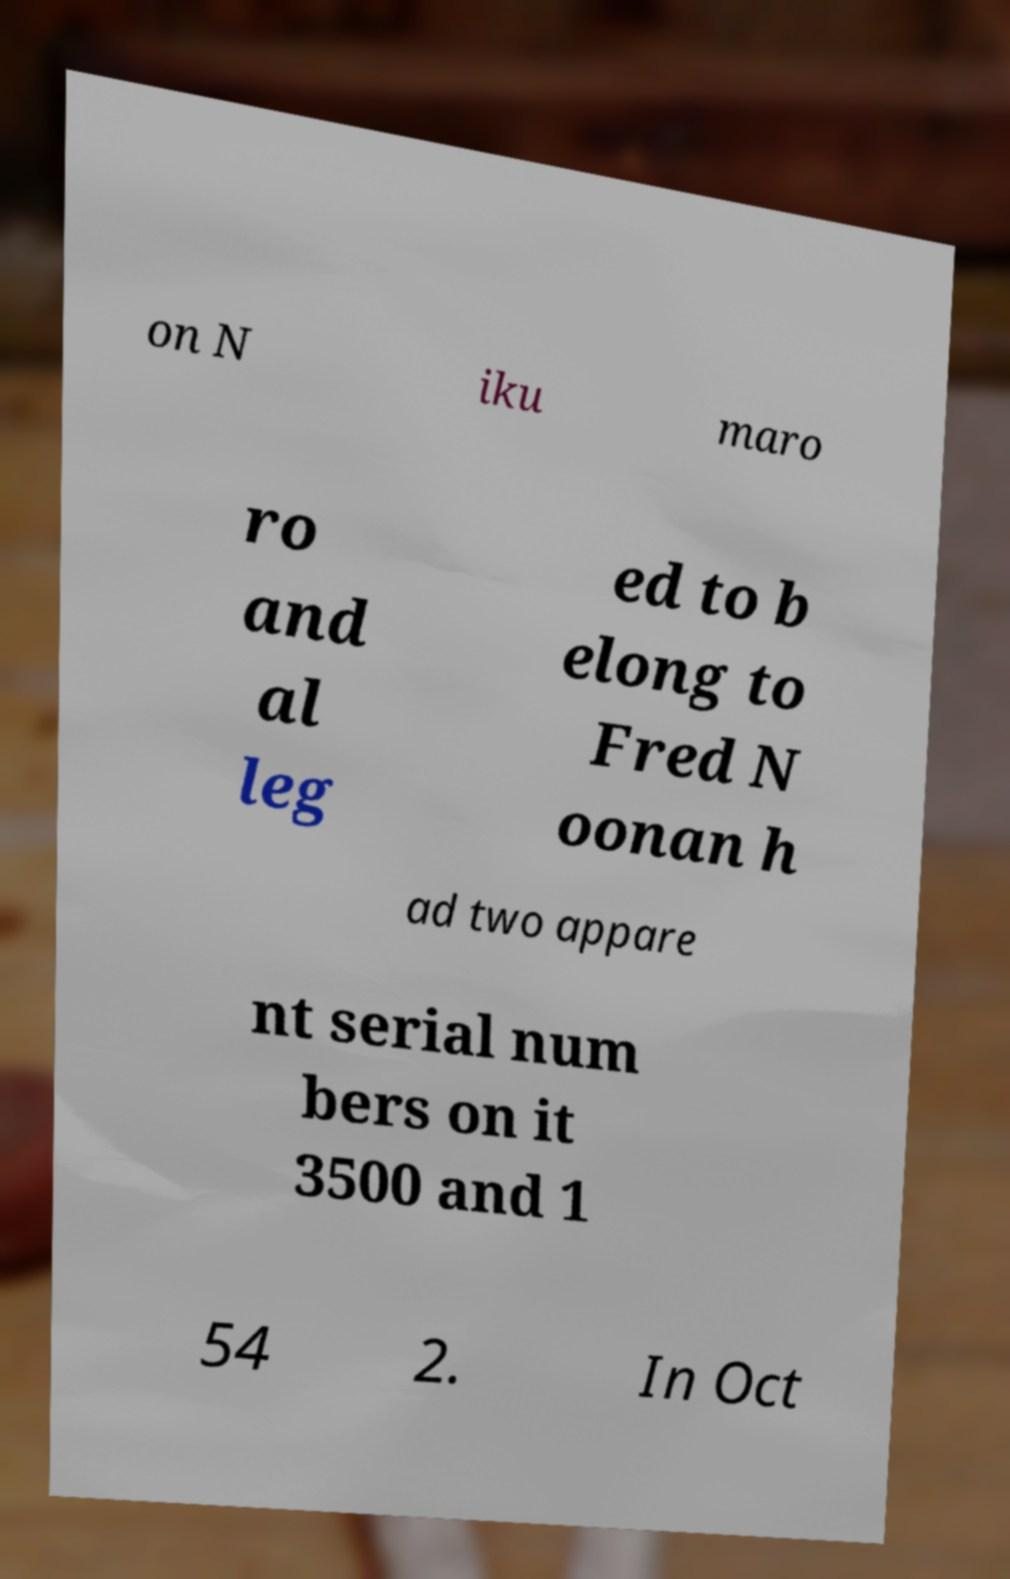I need the written content from this picture converted into text. Can you do that? on N iku maro ro and al leg ed to b elong to Fred N oonan h ad two appare nt serial num bers on it 3500 and 1 54 2. In Oct 